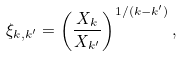Convert formula to latex. <formula><loc_0><loc_0><loc_500><loc_500>\xi _ { k , k ^ { \prime } } = \left ( \frac { X _ { k } } { X _ { k ^ { \prime } } } \right ) ^ { 1 / ( k - k ^ { \prime } ) } ,</formula> 